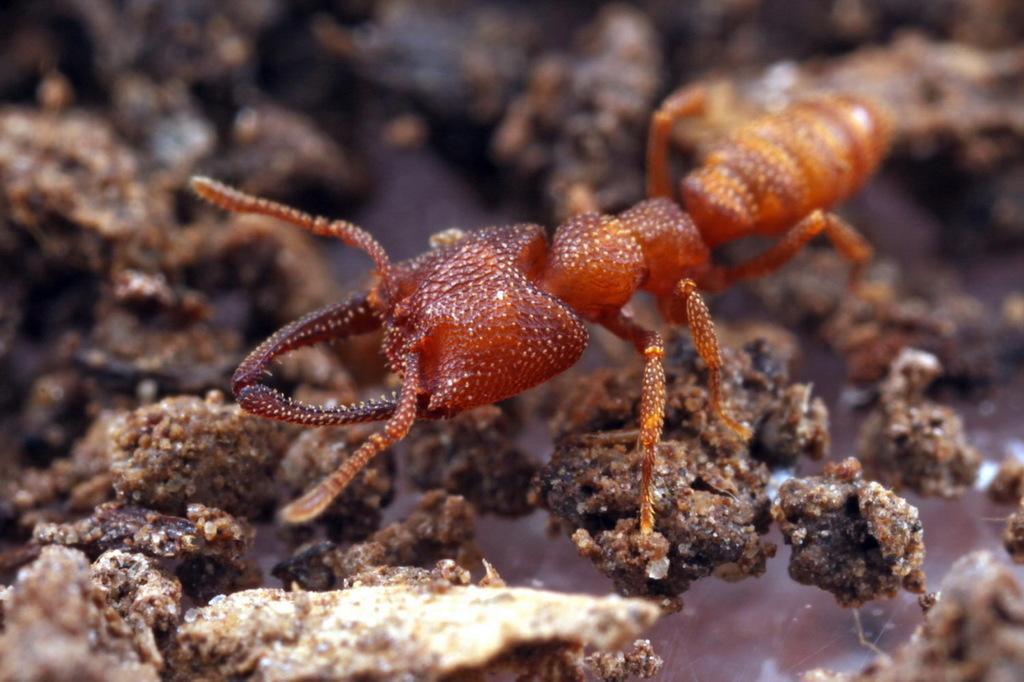Could you give a brief overview of what you see in this image? In this picture we observe a small brown insect crawling on the mud stones. 